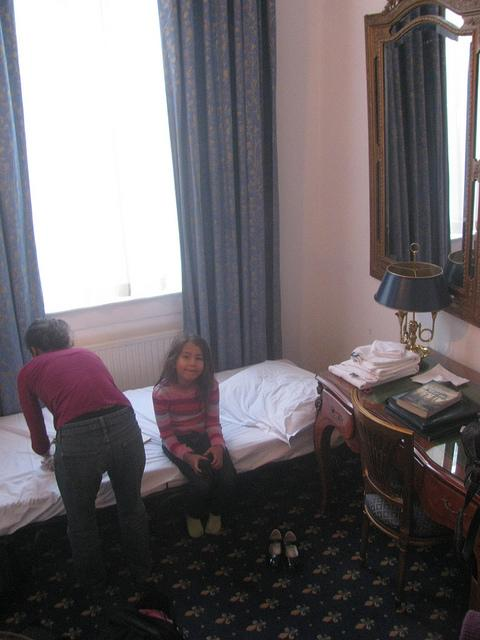Why does she haver her shoes off?

Choices:
A) in bed
B) too hot
C) confused
D) dislikes shoes in bed 